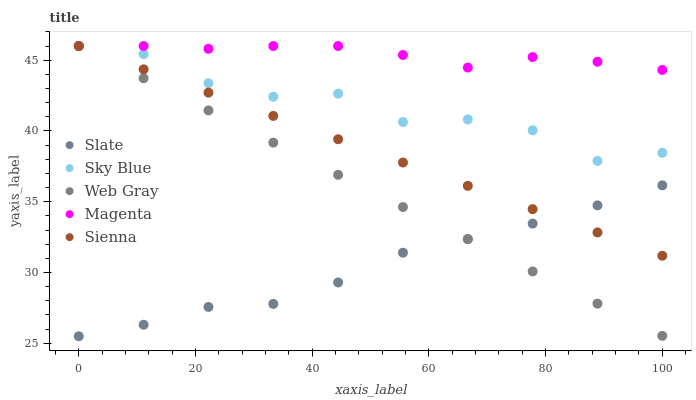Does Slate have the minimum area under the curve?
Answer yes or no. Yes. Does Magenta have the maximum area under the curve?
Answer yes or no. Yes. Does Sky Blue have the minimum area under the curve?
Answer yes or no. No. Does Sky Blue have the maximum area under the curve?
Answer yes or no. No. Is Sienna the smoothest?
Answer yes or no. Yes. Is Sky Blue the roughest?
Answer yes or no. Yes. Is Slate the smoothest?
Answer yes or no. No. Is Slate the roughest?
Answer yes or no. No. Does Slate have the lowest value?
Answer yes or no. Yes. Does Sky Blue have the lowest value?
Answer yes or no. No. Does Magenta have the highest value?
Answer yes or no. Yes. Does Slate have the highest value?
Answer yes or no. No. Is Slate less than Magenta?
Answer yes or no. Yes. Is Magenta greater than Slate?
Answer yes or no. Yes. Does Magenta intersect Sienna?
Answer yes or no. Yes. Is Magenta less than Sienna?
Answer yes or no. No. Is Magenta greater than Sienna?
Answer yes or no. No. Does Slate intersect Magenta?
Answer yes or no. No. 